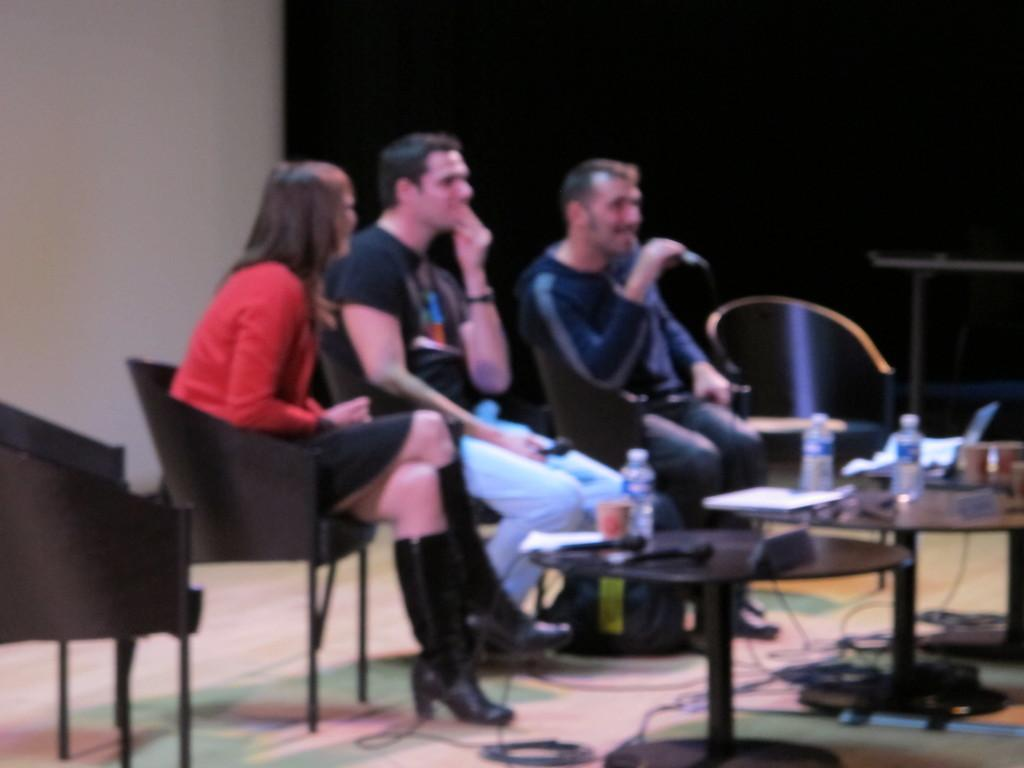How many people are in the image? There are two men and a woman in the image, making a total of three people. What are the individuals doing in the image? The individuals are sitting on chairs. How many chairs are visible in the image? There is a chair on either side of the seated individuals, making a total of three chairs. What is in front of the seated individuals? There is a table in front of the seated individuals. What can be found on the table? There are various items on the table. What type of engine is visible on the table in the image? There is no engine present on the table in the image. Can you describe the frog's attempt to climb the chair in the image? There is no frog present in the image, and therefore no such action can be observed. 